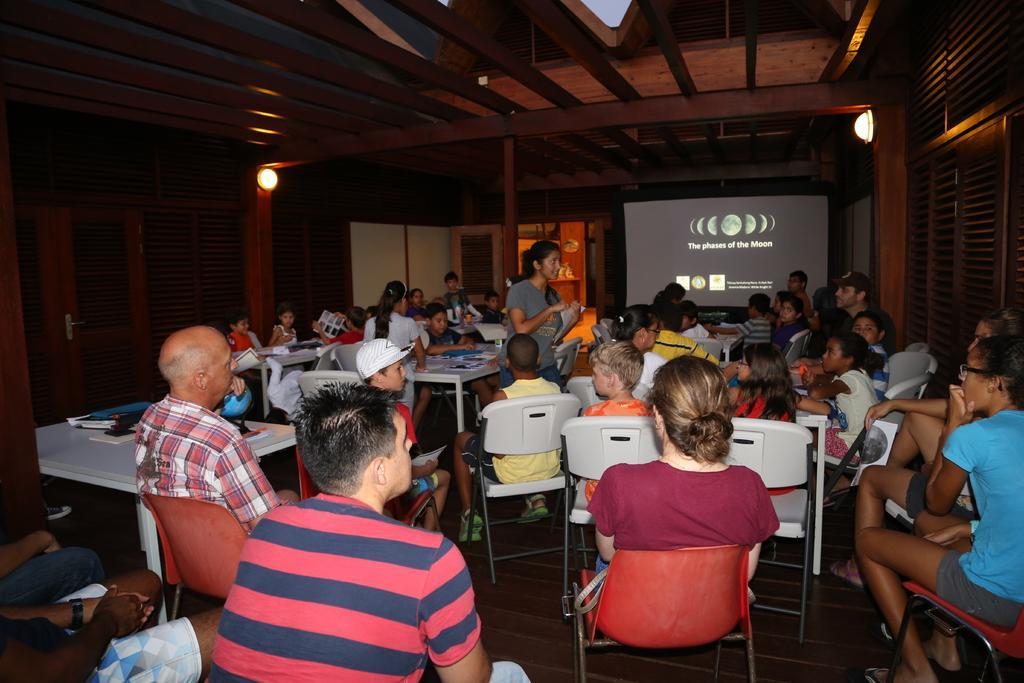Describe this image in one or two sentences. In the image there are many people sat on chair,there is a projector screen in the front,this seems to be a parents teachers meeting. 